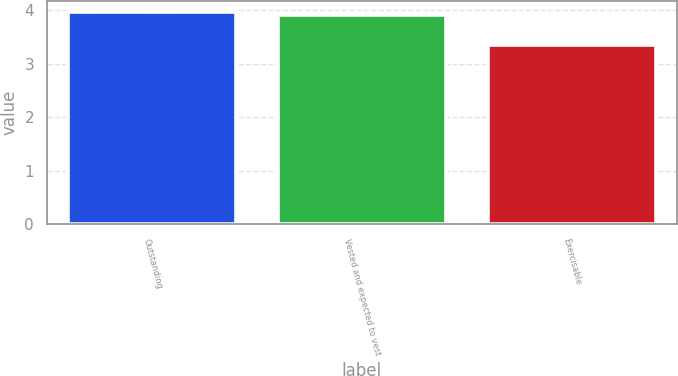<chart> <loc_0><loc_0><loc_500><loc_500><bar_chart><fcel>Outstanding<fcel>Vested and expected to vest<fcel>Exercisable<nl><fcel>3.97<fcel>3.91<fcel>3.36<nl></chart> 